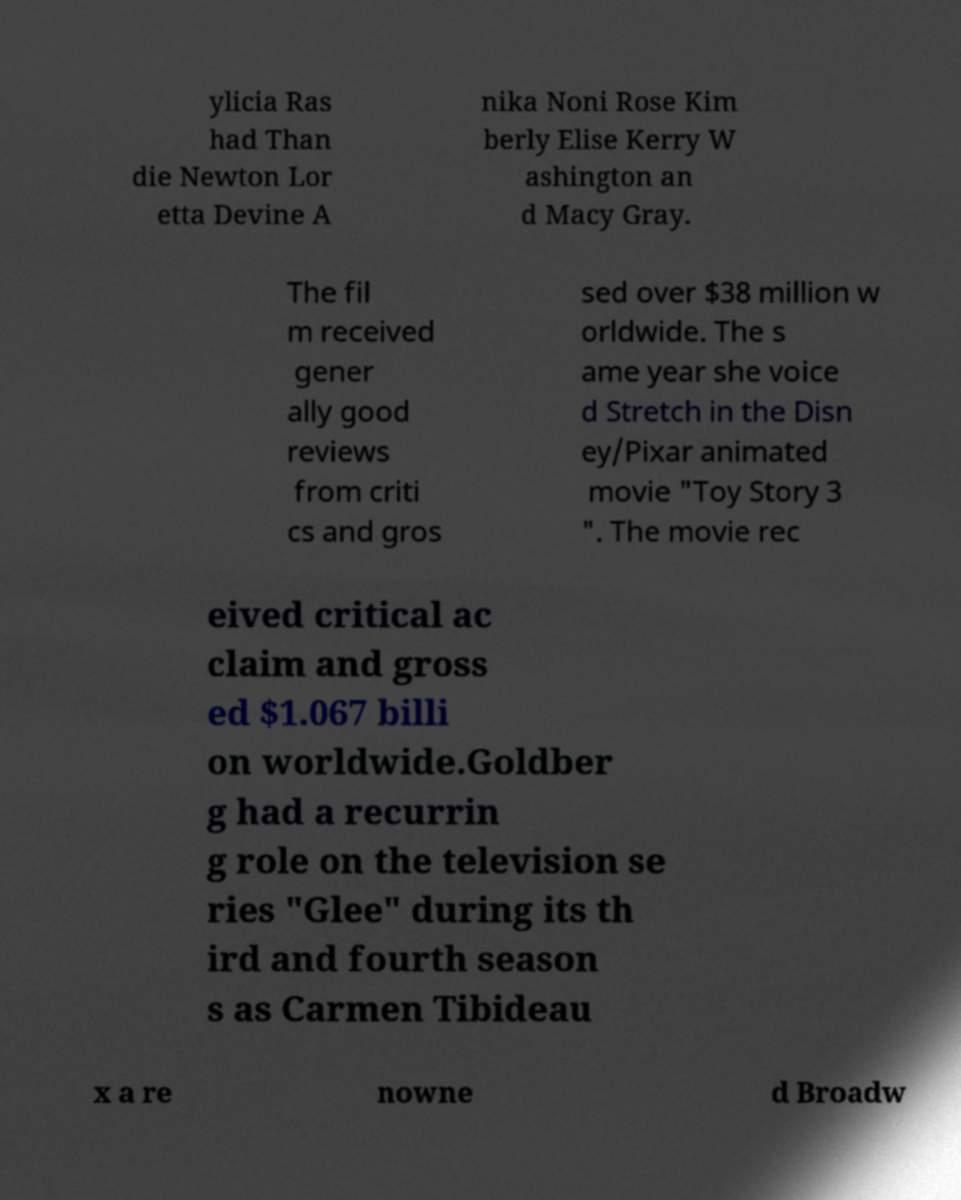Could you extract and type out the text from this image? ylicia Ras had Than die Newton Lor etta Devine A nika Noni Rose Kim berly Elise Kerry W ashington an d Macy Gray. The fil m received gener ally good reviews from criti cs and gros sed over $38 million w orldwide. The s ame year she voice d Stretch in the Disn ey/Pixar animated movie "Toy Story 3 ". The movie rec eived critical ac claim and gross ed $1.067 billi on worldwide.Goldber g had a recurrin g role on the television se ries "Glee" during its th ird and fourth season s as Carmen Tibideau x a re nowne d Broadw 